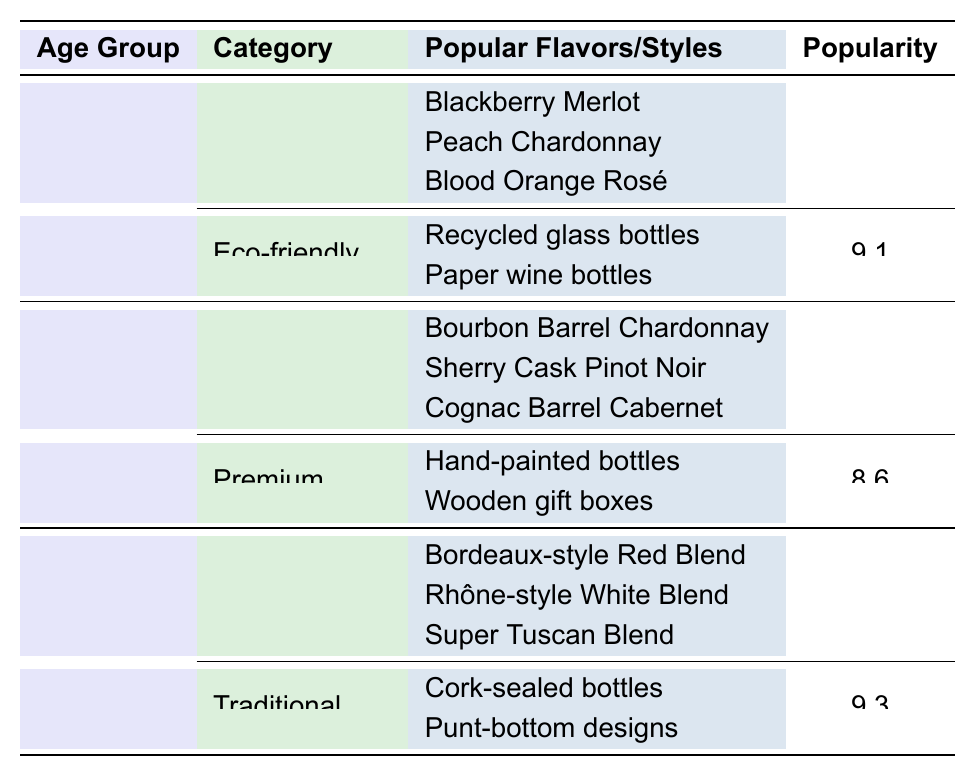What is the most popular packaging style for the 21-35 age group? The table shows that within the 21-35 age group, the most popular packaging style is "Eco-friendly" with a popularity score of 9.1.
Answer: Eco-friendly Which flavor category has the highest popularity score for the age group 51+? The table indicates that for the age group 51+, the "Classic blends" flavor category has the highest popularity score of 9.2.
Answer: Classic blends What are the popular flavors in the "Spice-infused" category for the 21-35 age group? The table lists the popular flavors in the "Spice-infused" category for the 21-35 age group as "Cinnamon Zinfandel," "Vanilla Bean Riesling," and "Cardamom Syrah."
Answer: Cinnamon Zinfandel, Vanilla Bean Riesling, Cardamom Syrah Is "Temperature-sensitive indicators" a popular packaging style for the 36-50 age group? According to the table, "Temperature-sensitive indicators" is listed under the "Smart packaging" type for the 36-50 age group, which has a popularity score of 7.8, indicating it is popular.
Answer: Yes What is the average popularity score of the packaging preferences for the age group 36-50? The table lists two packaging preferences for the 36-50 age group: "Premium" with a score of 8.6 and "Smart packaging" with a score of 7.8. The average is calculated as (8.6 + 7.8) / 2 = 8.2.
Answer: 8.2 How does the popularity of "Herb-infused" flavors compare to "Spice-infused" flavors for the 21-35 age group? For the 21-35 age group, "Herb-infused" flavors have a popularity score of 7.2 while "Spice-infused" flavors have a score of 6.8. The comparison shows that "Herb-infused" flavors are more popular than "Spice-infused" flavors.
Answer: Herb-infused flavors are more popular Which flavor category has a popularity score lower than 8 for any age group? Reviewing the table, the "Low-alcohol" category for the 36-50 age group has a popularity score of 7.5, which is lower than 8.
Answer: Low-alcohol What can be inferred about consumer preferences for packaging styles across different age groups? The table indicates that younger consumers (21-35) prefer eco-friendly and convenient packaging, while older groups (51+) lean toward traditional and collectible styles, suggesting a trend towards sustainability in younger consumers.
Answer: Younger consumers prefer eco-friendly packaging Which age group shows the highest popularity score for "Dessert wines"? The age group 51+ shows a popularity score of 7.9 for "Dessert wines," which is the highest score for this flavor category across all age groups listed in the table.
Answer: 51+ What is the total number of popular flavors listed for the 36-50 age group? The table indicates that there are three flavor categories listed for the 36-50 age group, each with three popular flavors: "Oak-aged," "Terroir-driven," and "Low-alcohol." Thus, the total number of popular flavors is 3 categories x 3 flavors = 9.
Answer: 9 